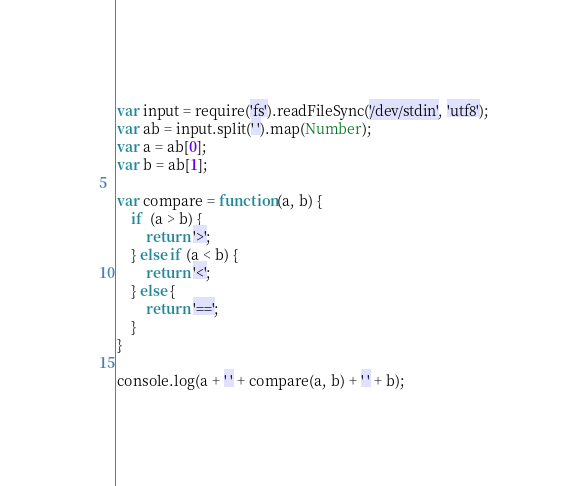<code> <loc_0><loc_0><loc_500><loc_500><_JavaScript_>var input = require('fs').readFileSync('/dev/stdin', 'utf8');
var ab = input.split(' ').map(Number);
var a = ab[0];
var b = ab[1];

var compare = function(a, b) {
	if  (a > b) {
	    return '>';
	} else if (a < b) {
        return '<';
    } else {
        return '==';
    }
}

console.log(a + ' ' + compare(a, b) + ' ' + b);</code> 